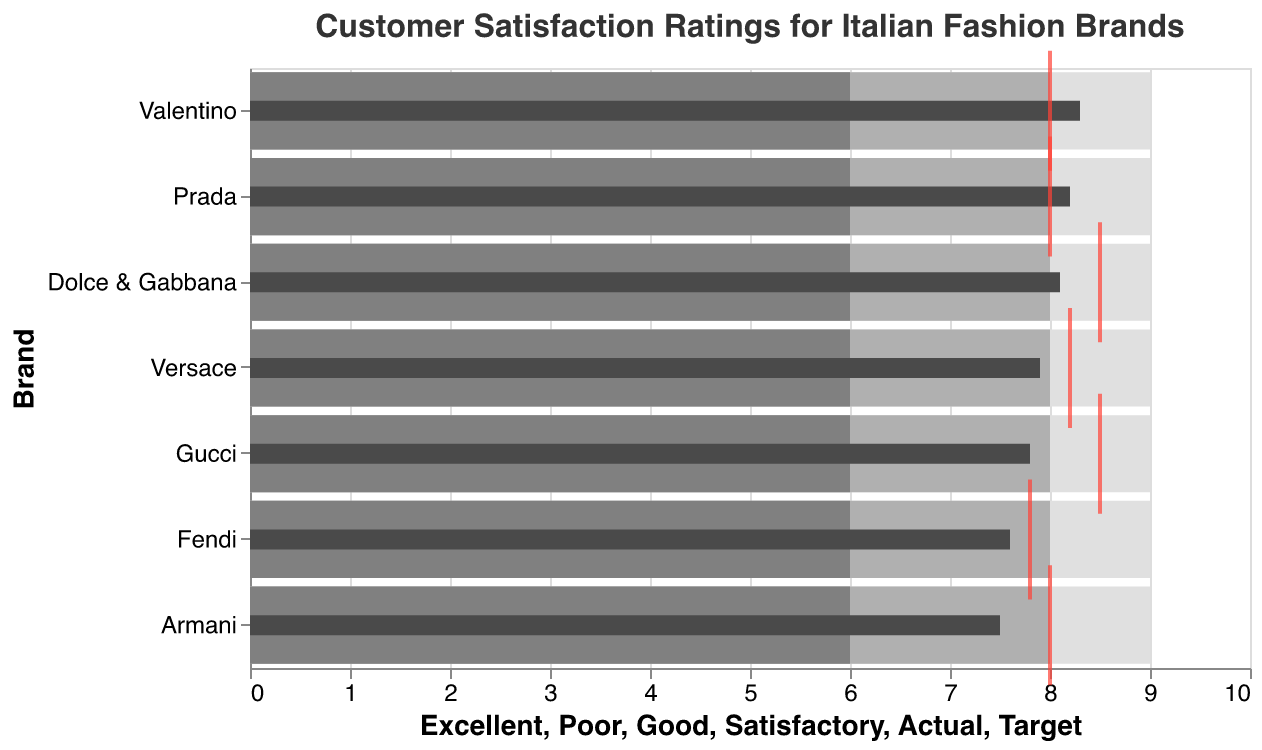What is the actual customer satisfaction rating for Gucci? Look at the bar representing Gucci. The dark grey bar shows the actual satisfaction rating. For Gucci, this value is 7.8.
Answer: 7.8 Which brand has the highest customer satisfaction rating? Compare the heights of the dark grey bars representing actual satisfaction ratings for all brands. Valentino has the highest rating.
Answer: Valentino What band of satisfaction does Prada fall into? Look at the bars that represent different bands of satisfaction for Prada. The actual rating for Prada is 8.2, which falls into the 'Good' and 'Excellent' range.
Answer: Good/Excellent Which brands have met or exceeded their target satisfaction rating? Compare the dark grey bar (actual rating) with the red tick (target rating) for each brand. Prada and Valentino have actual ratings equal to or greater than their targets.
Answer: Prada, Valentino What's the difference between Dolce & Gabbana's actual and target ratings? The actual rating for Dolce & Gabbana is 8.1 and the target rating is 8.5. The difference is 8.5 - 8.1 = 0.4.
Answer: 0.4 Which brand has the largest gap between actual and target satisfaction ratings? Calculate the differences between the actual and target ratings for each brand. Gucci has the largest difference of 8.5 - 7.8 = 0.7.
Answer: Gucci How many brands have an actual customer satisfaction rating of 8 or higher? Count the brands with dark grey bars representing actual satisfaction ratings of 8 or above. Prada, Dolce & Gabbana, and Valentino meet this criterion.
Answer: 3 What are the satisfactory and good rating thresholds? The satisfactory rating threshold is indicated by the lightest grey bar and the good rating threshold by the medium grey bar. The thresholds are 6 for satisfactory, and 8 for good as per figure.
Answer: Satisfactory: 6, Good: 8 Which brands have actual ratings that are below their target but within the excellent range? Check the dark grey bars against the red ticks, and see which fall below the target but are within the range of 9 (excellent). Versace's actual rating is 7.9, which is below its target of 8.2 but within the excellent range.
Answer: Versace 